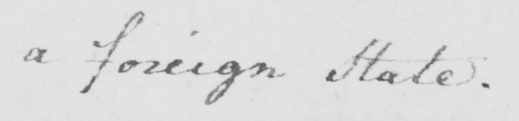Transcribe the text shown in this historical manuscript line. a foreign State . 